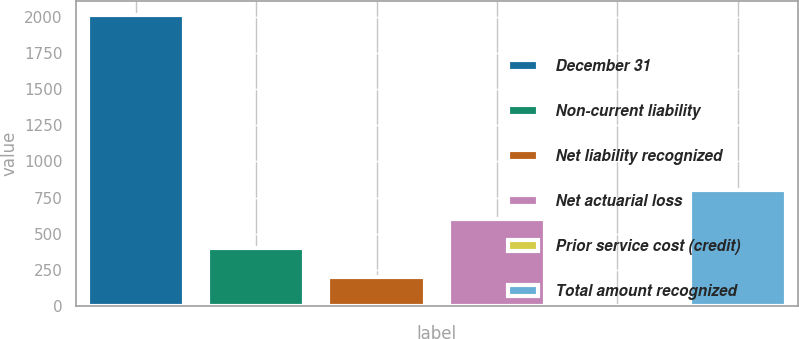Convert chart. <chart><loc_0><loc_0><loc_500><loc_500><bar_chart><fcel>December 31<fcel>Non-current liability<fcel>Net liability recognized<fcel>Net actuarial loss<fcel>Prior service cost (credit)<fcel>Total amount recognized<nl><fcel>2009<fcel>401.88<fcel>200.99<fcel>602.77<fcel>0.1<fcel>803.66<nl></chart> 